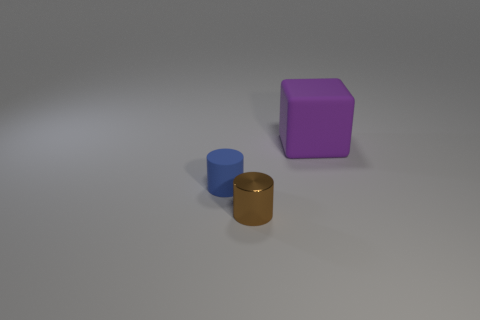Are the thing behind the small blue cylinder and the small blue cylinder made of the same material? While the objects share a similar matte finish, without more specific information it's difficult to confirm if they are made of exactly the same material. They could possibly be made from different types of plastics or metals but treated to achieve a similar appearance in terms of color and texture. 